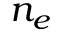Convert formula to latex. <formula><loc_0><loc_0><loc_500><loc_500>n _ { e }</formula> 